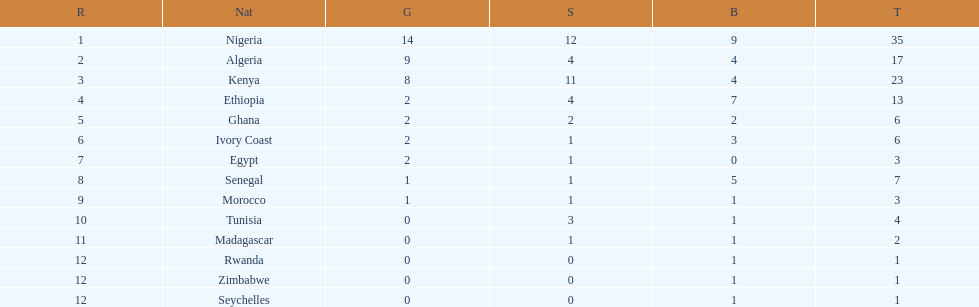What is the name of the only nation that did not earn any bronze medals? Egypt. 